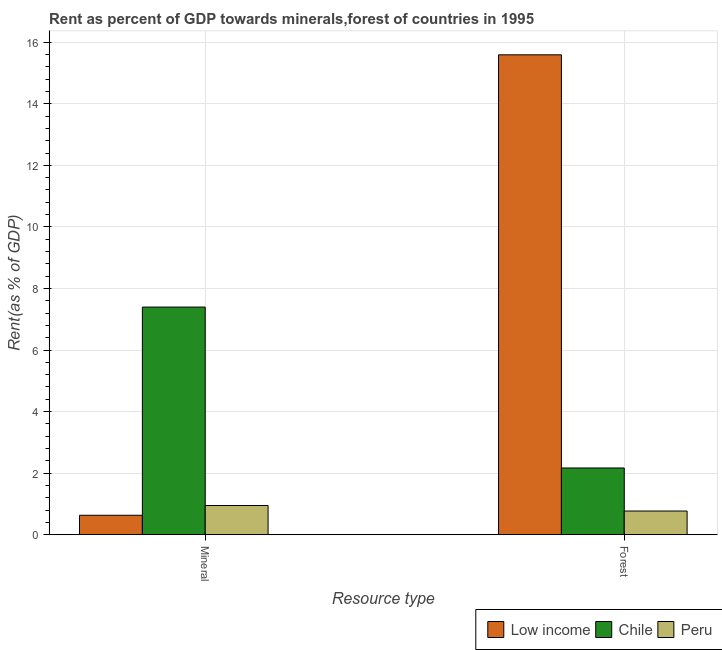How many bars are there on the 2nd tick from the right?
Provide a succinct answer. 3. What is the label of the 1st group of bars from the left?
Give a very brief answer. Mineral. What is the forest rent in Low income?
Provide a short and direct response. 15.59. Across all countries, what is the maximum mineral rent?
Provide a short and direct response. 7.4. Across all countries, what is the minimum forest rent?
Provide a succinct answer. 0.77. What is the total mineral rent in the graph?
Your answer should be compact. 8.98. What is the difference between the forest rent in Chile and that in Peru?
Offer a terse response. 1.4. What is the difference between the mineral rent in Low income and the forest rent in Peru?
Your answer should be compact. -0.14. What is the average forest rent per country?
Your answer should be very brief. 6.18. What is the difference between the mineral rent and forest rent in Chile?
Provide a short and direct response. 5.23. What is the ratio of the mineral rent in Peru to that in Chile?
Provide a succinct answer. 0.13. In how many countries, is the forest rent greater than the average forest rent taken over all countries?
Ensure brevity in your answer.  1. What does the 2nd bar from the left in Mineral represents?
Ensure brevity in your answer.  Chile. What does the 1st bar from the right in Mineral represents?
Your answer should be compact. Peru. Are all the bars in the graph horizontal?
Ensure brevity in your answer.  No. How many countries are there in the graph?
Offer a very short reply. 3. How many legend labels are there?
Your answer should be compact. 3. How are the legend labels stacked?
Keep it short and to the point. Horizontal. What is the title of the graph?
Give a very brief answer. Rent as percent of GDP towards minerals,forest of countries in 1995. Does "Macao" appear as one of the legend labels in the graph?
Offer a very short reply. No. What is the label or title of the X-axis?
Ensure brevity in your answer.  Resource type. What is the label or title of the Y-axis?
Keep it short and to the point. Rent(as % of GDP). What is the Rent(as % of GDP) of Low income in Mineral?
Give a very brief answer. 0.63. What is the Rent(as % of GDP) of Chile in Mineral?
Your answer should be compact. 7.4. What is the Rent(as % of GDP) of Peru in Mineral?
Your answer should be compact. 0.95. What is the Rent(as % of GDP) in Low income in Forest?
Offer a very short reply. 15.59. What is the Rent(as % of GDP) in Chile in Forest?
Your answer should be very brief. 2.17. What is the Rent(as % of GDP) of Peru in Forest?
Your response must be concise. 0.77. Across all Resource type, what is the maximum Rent(as % of GDP) in Low income?
Provide a succinct answer. 15.59. Across all Resource type, what is the maximum Rent(as % of GDP) in Chile?
Your response must be concise. 7.4. Across all Resource type, what is the maximum Rent(as % of GDP) of Peru?
Provide a short and direct response. 0.95. Across all Resource type, what is the minimum Rent(as % of GDP) in Low income?
Keep it short and to the point. 0.63. Across all Resource type, what is the minimum Rent(as % of GDP) of Chile?
Your answer should be compact. 2.17. Across all Resource type, what is the minimum Rent(as % of GDP) in Peru?
Your answer should be very brief. 0.77. What is the total Rent(as % of GDP) of Low income in the graph?
Provide a succinct answer. 16.22. What is the total Rent(as % of GDP) in Chile in the graph?
Give a very brief answer. 9.56. What is the total Rent(as % of GDP) of Peru in the graph?
Keep it short and to the point. 1.72. What is the difference between the Rent(as % of GDP) in Low income in Mineral and that in Forest?
Offer a terse response. -14.96. What is the difference between the Rent(as % of GDP) of Chile in Mineral and that in Forest?
Keep it short and to the point. 5.23. What is the difference between the Rent(as % of GDP) in Peru in Mineral and that in Forest?
Make the answer very short. 0.18. What is the difference between the Rent(as % of GDP) in Low income in Mineral and the Rent(as % of GDP) in Chile in Forest?
Keep it short and to the point. -1.54. What is the difference between the Rent(as % of GDP) of Low income in Mineral and the Rent(as % of GDP) of Peru in Forest?
Provide a short and direct response. -0.14. What is the difference between the Rent(as % of GDP) of Chile in Mineral and the Rent(as % of GDP) of Peru in Forest?
Your answer should be very brief. 6.63. What is the average Rent(as % of GDP) of Low income per Resource type?
Offer a very short reply. 8.11. What is the average Rent(as % of GDP) of Chile per Resource type?
Ensure brevity in your answer.  4.78. What is the average Rent(as % of GDP) in Peru per Resource type?
Offer a very short reply. 0.86. What is the difference between the Rent(as % of GDP) in Low income and Rent(as % of GDP) in Chile in Mineral?
Provide a short and direct response. -6.76. What is the difference between the Rent(as % of GDP) in Low income and Rent(as % of GDP) in Peru in Mineral?
Make the answer very short. -0.32. What is the difference between the Rent(as % of GDP) of Chile and Rent(as % of GDP) of Peru in Mineral?
Your response must be concise. 6.45. What is the difference between the Rent(as % of GDP) of Low income and Rent(as % of GDP) of Chile in Forest?
Give a very brief answer. 13.42. What is the difference between the Rent(as % of GDP) in Low income and Rent(as % of GDP) in Peru in Forest?
Give a very brief answer. 14.82. What is the difference between the Rent(as % of GDP) of Chile and Rent(as % of GDP) of Peru in Forest?
Your answer should be very brief. 1.4. What is the ratio of the Rent(as % of GDP) in Low income in Mineral to that in Forest?
Provide a succinct answer. 0.04. What is the ratio of the Rent(as % of GDP) of Chile in Mineral to that in Forest?
Make the answer very short. 3.41. What is the ratio of the Rent(as % of GDP) in Peru in Mineral to that in Forest?
Give a very brief answer. 1.23. What is the difference between the highest and the second highest Rent(as % of GDP) of Low income?
Make the answer very short. 14.96. What is the difference between the highest and the second highest Rent(as % of GDP) of Chile?
Your response must be concise. 5.23. What is the difference between the highest and the second highest Rent(as % of GDP) of Peru?
Offer a very short reply. 0.18. What is the difference between the highest and the lowest Rent(as % of GDP) of Low income?
Provide a succinct answer. 14.96. What is the difference between the highest and the lowest Rent(as % of GDP) of Chile?
Offer a very short reply. 5.23. What is the difference between the highest and the lowest Rent(as % of GDP) of Peru?
Your response must be concise. 0.18. 